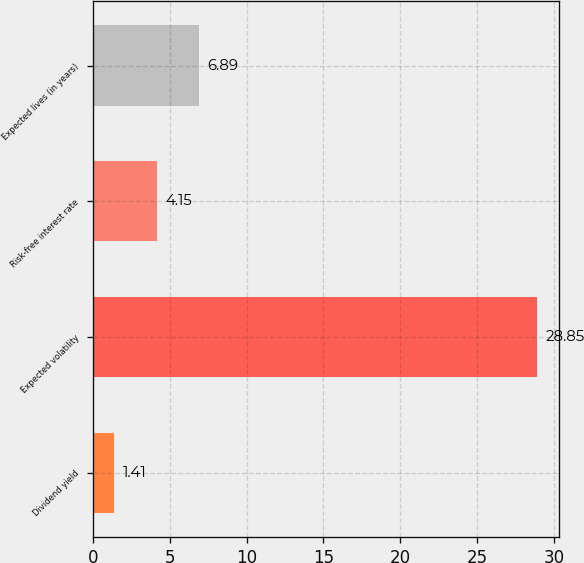<chart> <loc_0><loc_0><loc_500><loc_500><bar_chart><fcel>Dividend yield<fcel>Expected volatility<fcel>Risk-free interest rate<fcel>Expected lives (in years)<nl><fcel>1.41<fcel>28.85<fcel>4.15<fcel>6.89<nl></chart> 